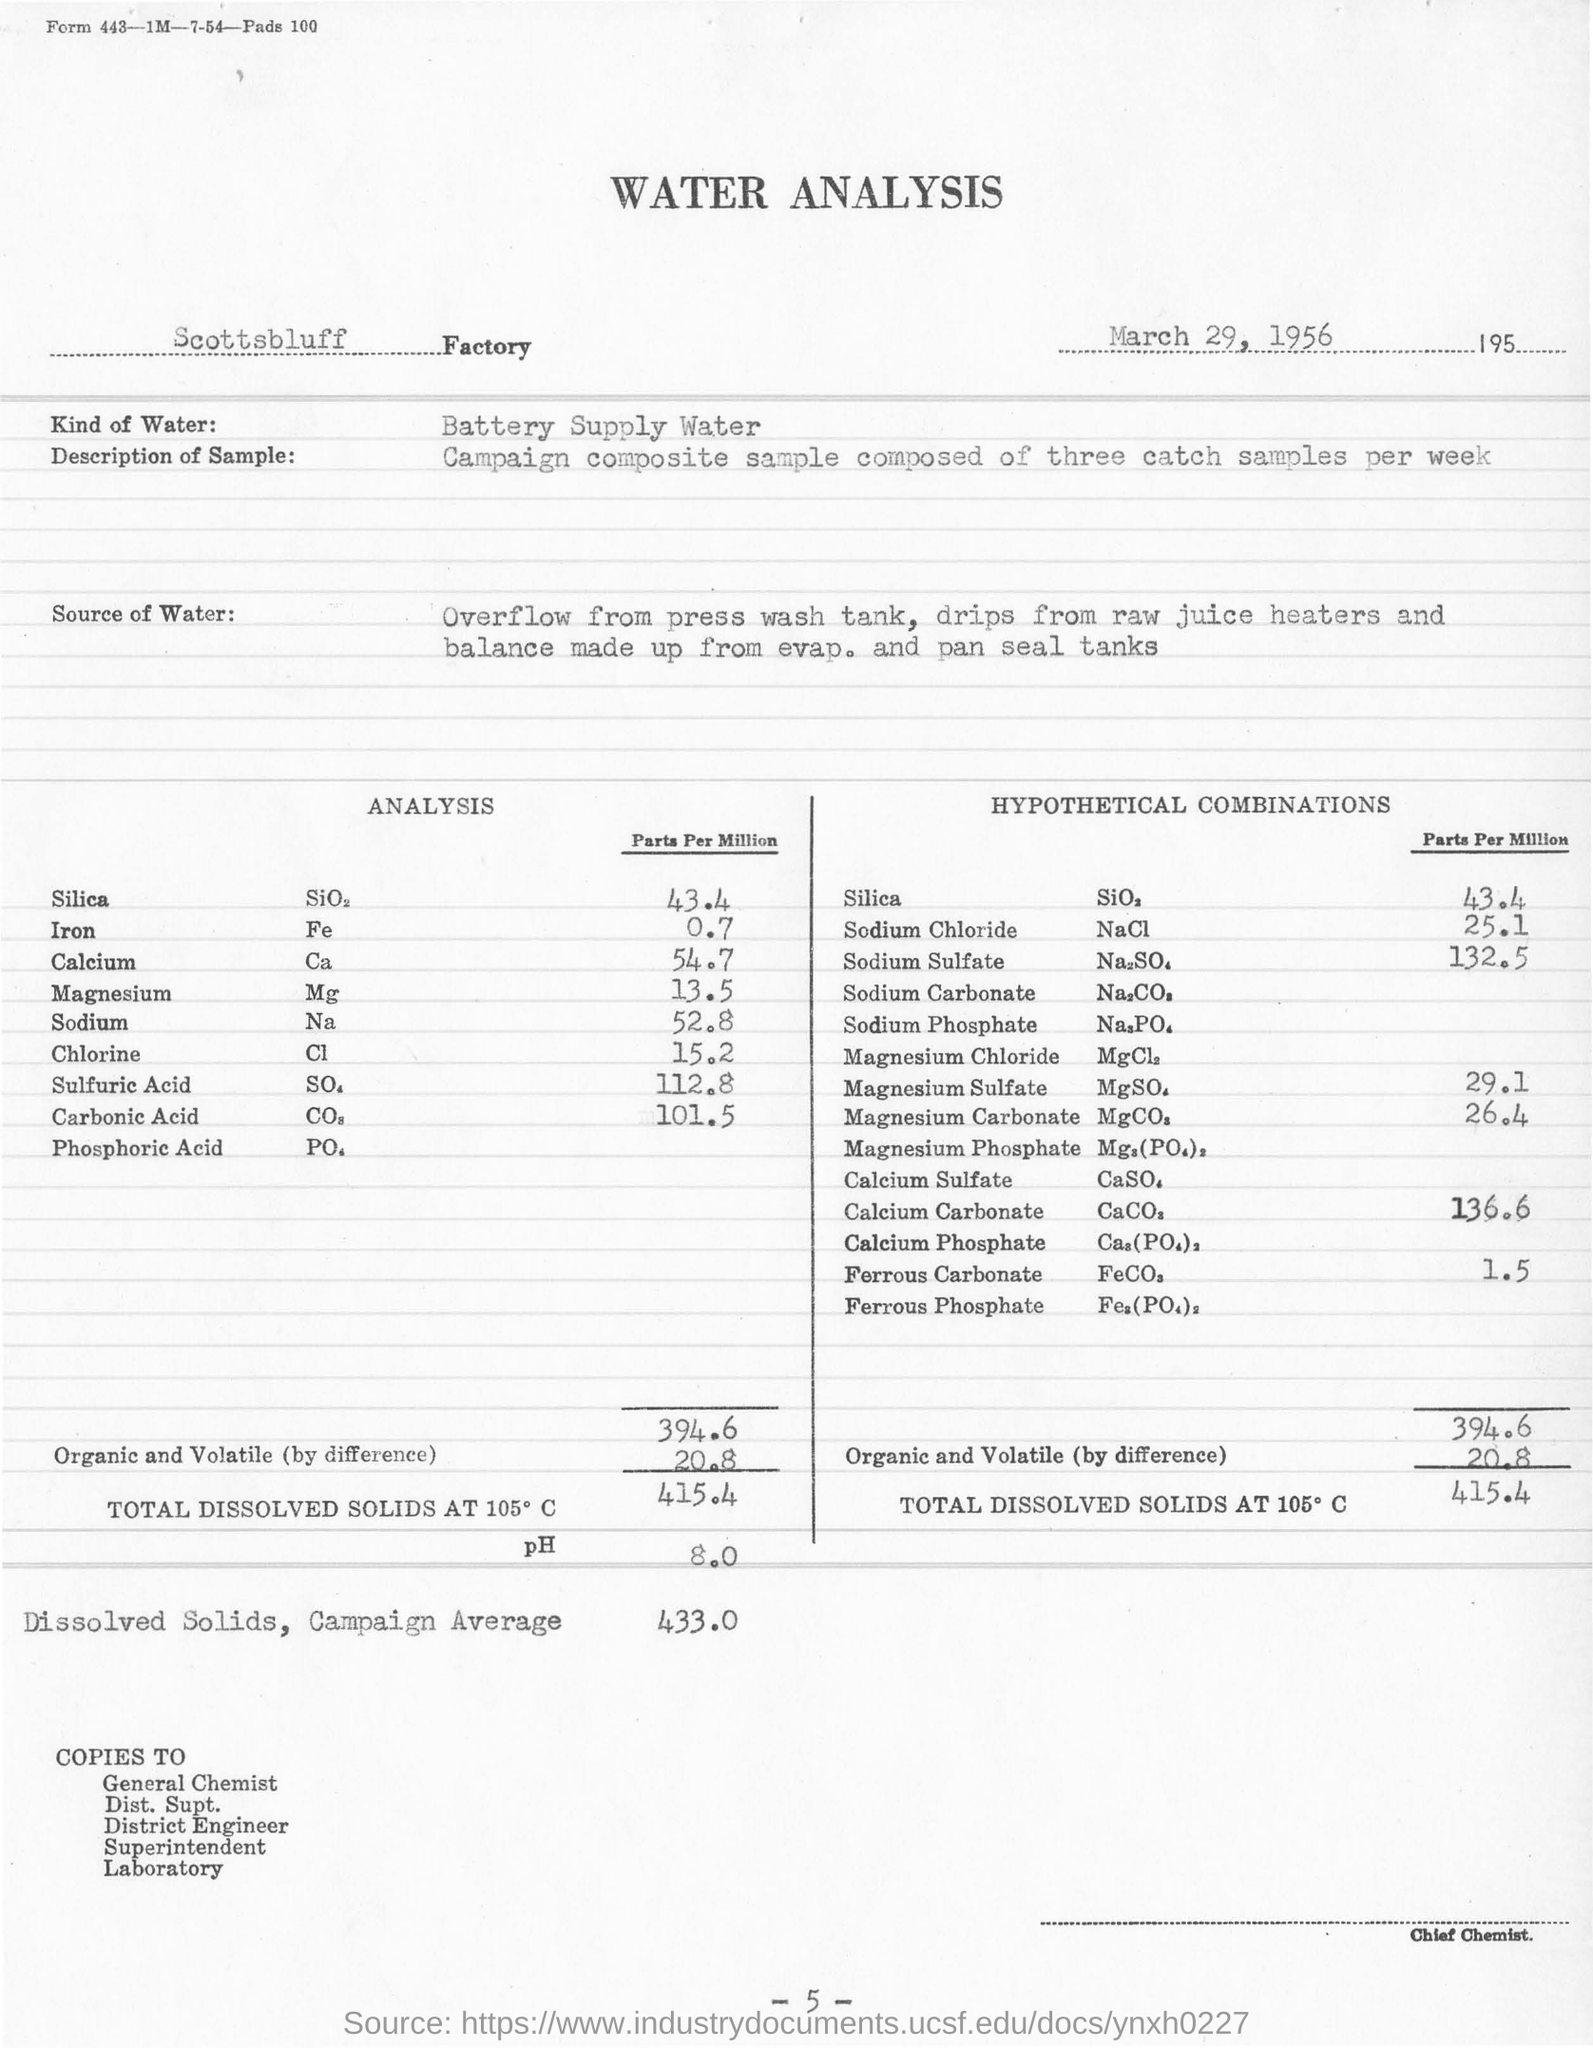How many water samples are collected per week?
Ensure brevity in your answer.  Three catch samples per week. Where is the Water Analysis conducted?
Your answer should be very brief. Scottsbluff factory. What is the units for the Chemicals used in the table?
Keep it short and to the point. Parts per Million. 